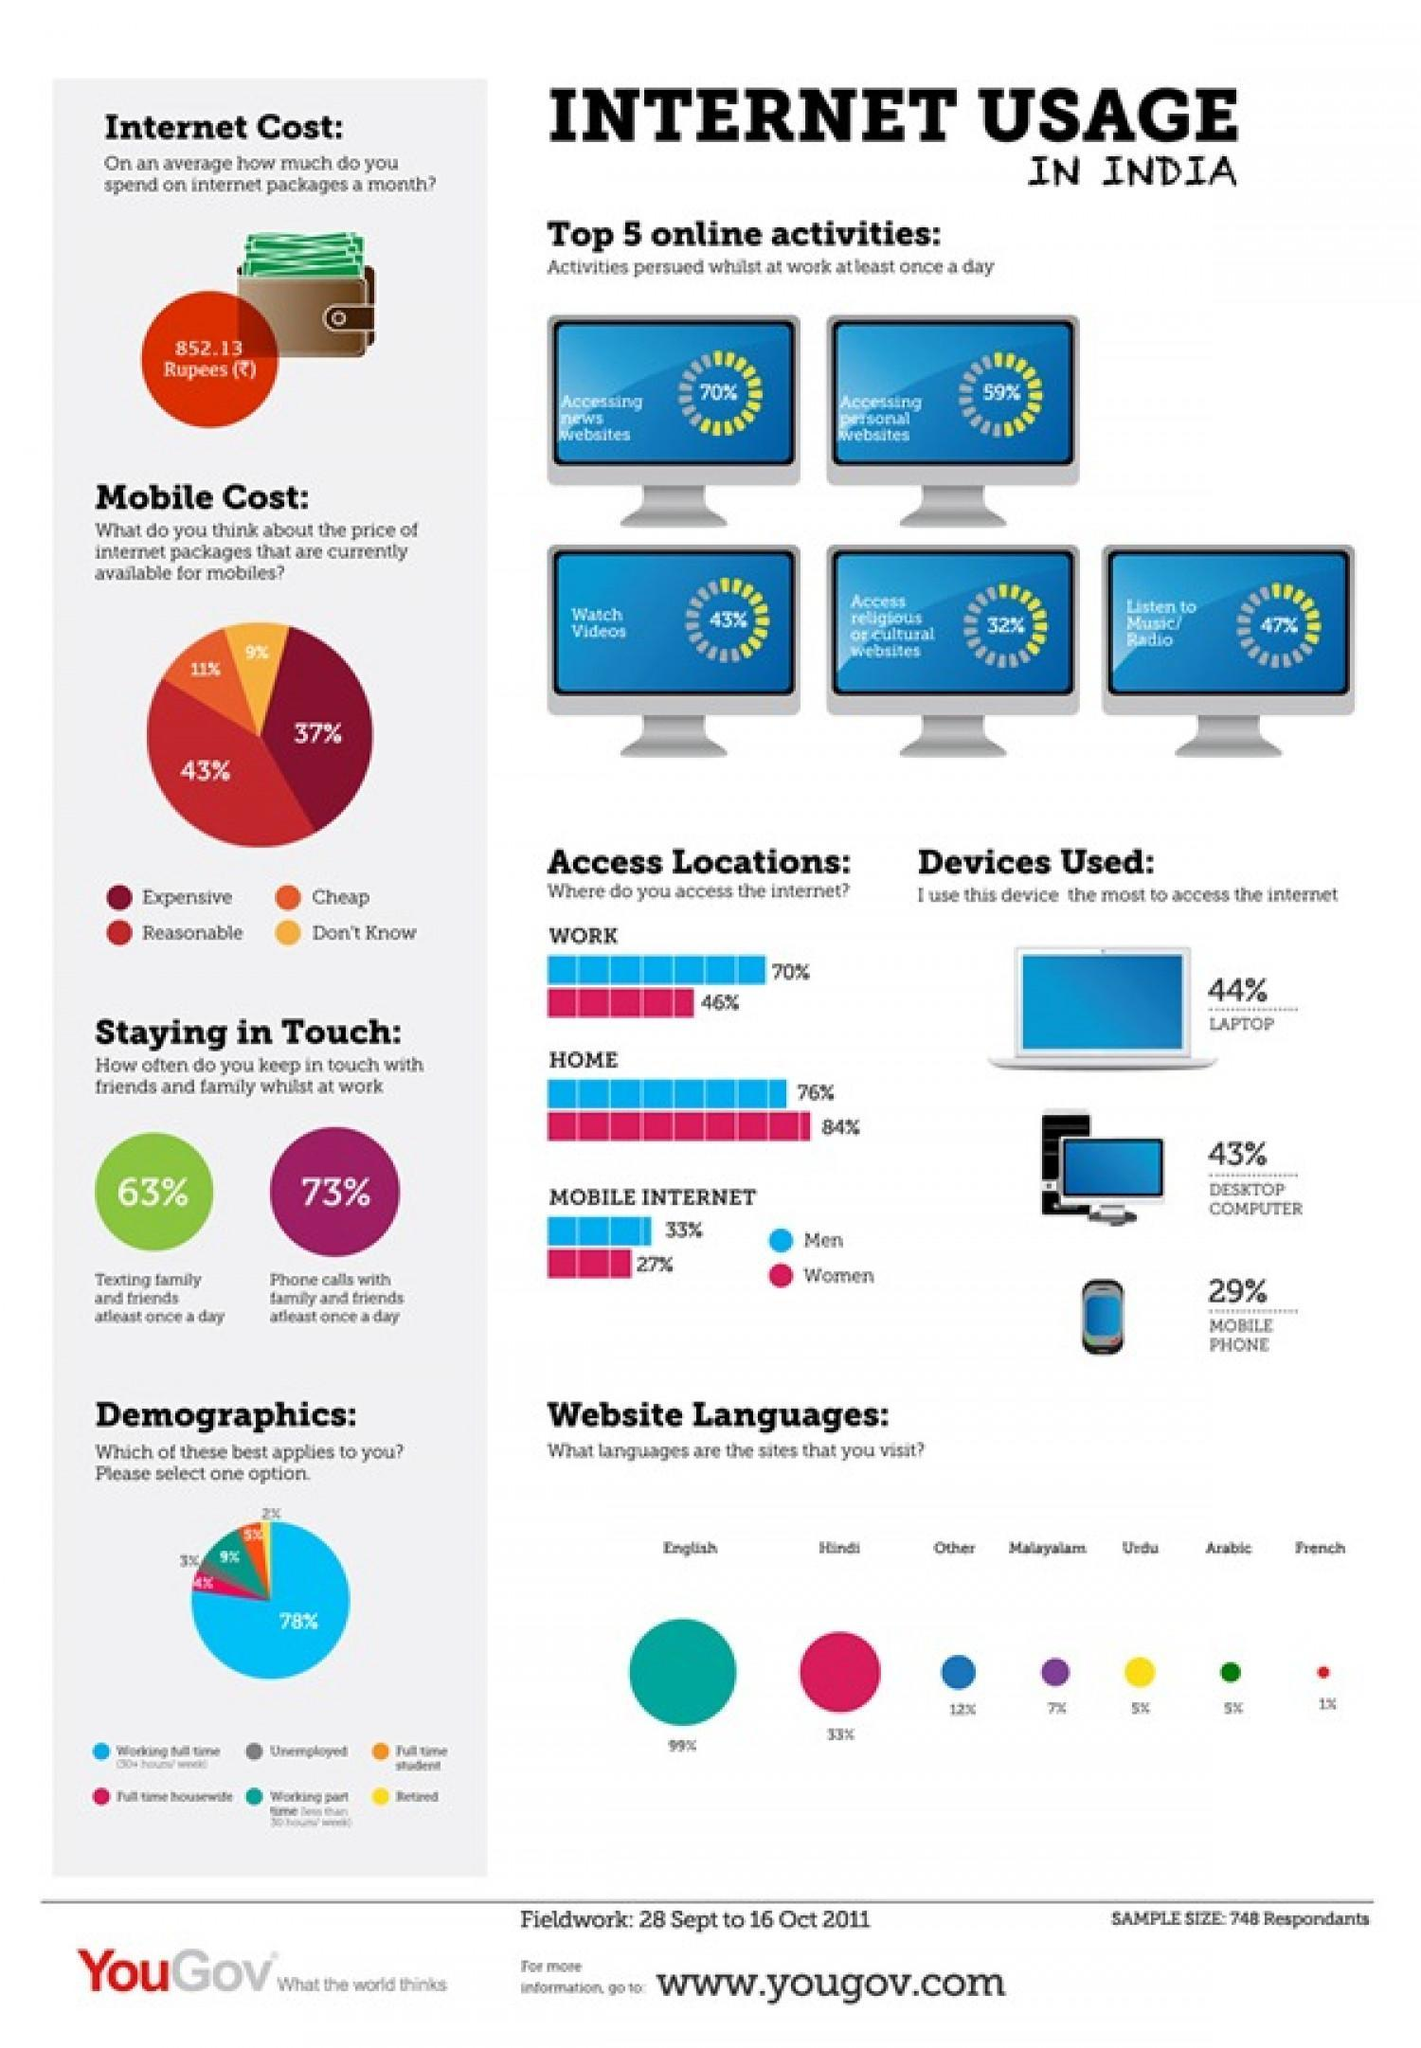What percentage of Indians think that the price of internet packages that are currently available for mobiles are reasonable according to the survey?
Answer the question with a short phrase. 43% What percentage of Indians think that the price of internet packages that are currently available for mobiles are cheap according to the survey? 11% Which is the most widely used website language by the Indians according to the survey? English What percent of Indians listen to music/radio while at work at least once in a day as per the survey? 47% Which is the least used website language by the Indians according to the survey? French What percentage of Indian men have access to the internet at home as per the survey? 76% Which is the second most used website language by the Indians according to the survey? Hindi What percentage of Indian women have access to mobile internet as per the survey? 27% Which device is mostly used by the Indians in order to access the internet according to the survey? LAPTOP What percentage of Indians think that the price of internet packages that are currently available for mobiles are expensive according to the survey? 37% 